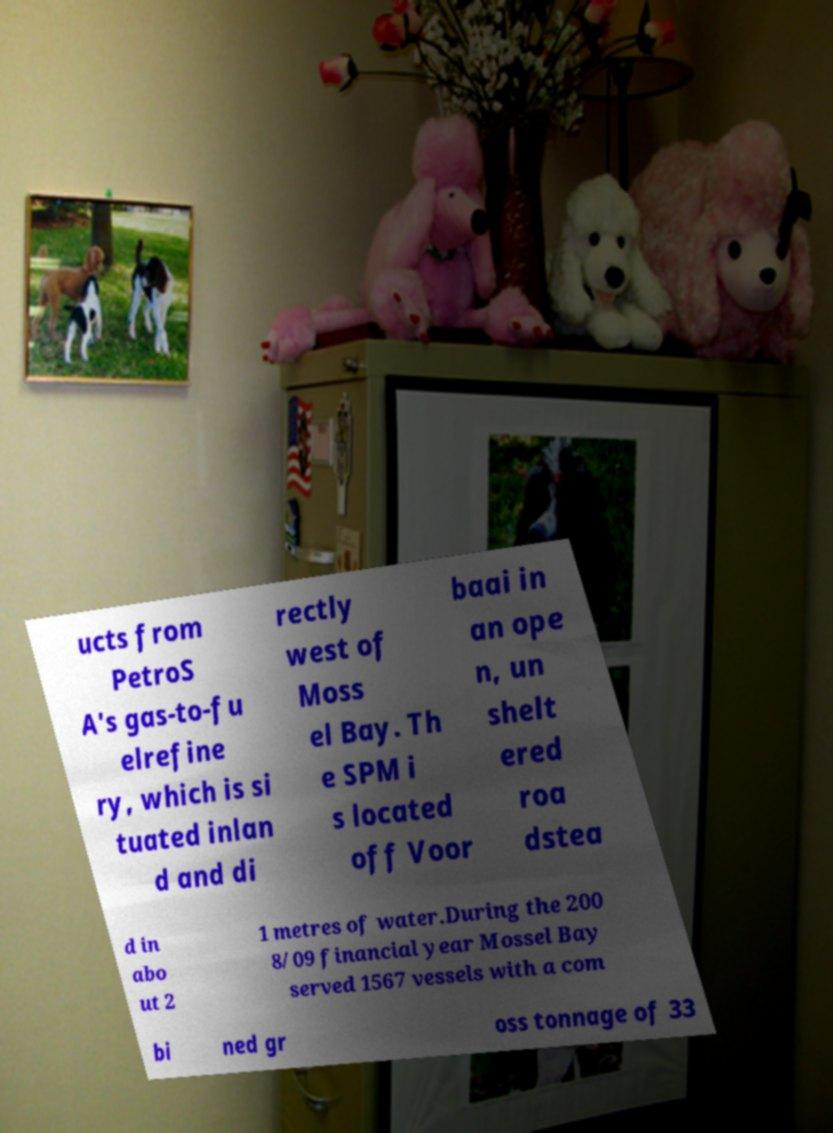Could you extract and type out the text from this image? ucts from PetroS A's gas-to-fu elrefine ry, which is si tuated inlan d and di rectly west of Moss el Bay. Th e SPM i s located off Voor baai in an ope n, un shelt ered roa dstea d in abo ut 2 1 metres of water.During the 200 8/09 financial year Mossel Bay served 1567 vessels with a com bi ned gr oss tonnage of 33 